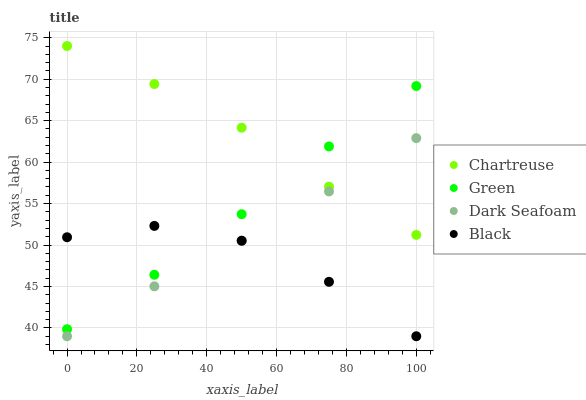Does Black have the minimum area under the curve?
Answer yes or no. Yes. Does Chartreuse have the maximum area under the curve?
Answer yes or no. Yes. Does Green have the minimum area under the curve?
Answer yes or no. No. Does Green have the maximum area under the curve?
Answer yes or no. No. Is Dark Seafoam the smoothest?
Answer yes or no. Yes. Is Black the roughest?
Answer yes or no. Yes. Is Chartreuse the smoothest?
Answer yes or no. No. Is Chartreuse the roughest?
Answer yes or no. No. Does Black have the lowest value?
Answer yes or no. Yes. Does Green have the lowest value?
Answer yes or no. No. Does Chartreuse have the highest value?
Answer yes or no. Yes. Does Green have the highest value?
Answer yes or no. No. Is Dark Seafoam less than Green?
Answer yes or no. Yes. Is Chartreuse greater than Black?
Answer yes or no. Yes. Does Chartreuse intersect Green?
Answer yes or no. Yes. Is Chartreuse less than Green?
Answer yes or no. No. Is Chartreuse greater than Green?
Answer yes or no. No. Does Dark Seafoam intersect Green?
Answer yes or no. No. 